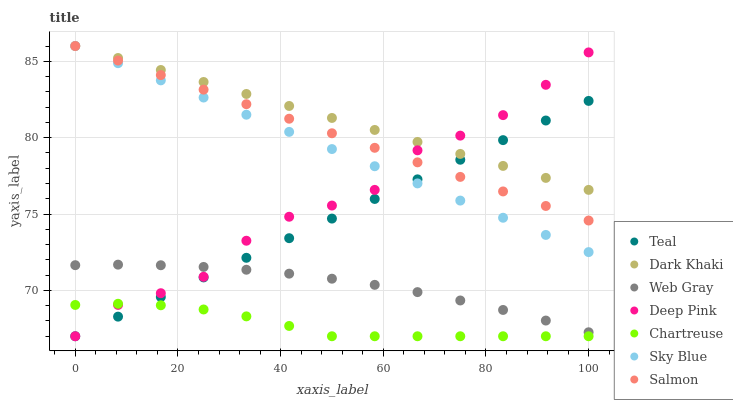Does Chartreuse have the minimum area under the curve?
Answer yes or no. Yes. Does Dark Khaki have the maximum area under the curve?
Answer yes or no. Yes. Does Salmon have the minimum area under the curve?
Answer yes or no. No. Does Salmon have the maximum area under the curve?
Answer yes or no. No. Is Sky Blue the smoothest?
Answer yes or no. Yes. Is Deep Pink the roughest?
Answer yes or no. Yes. Is Salmon the smoothest?
Answer yes or no. No. Is Salmon the roughest?
Answer yes or no. No. Does Chartreuse have the lowest value?
Answer yes or no. Yes. Does Salmon have the lowest value?
Answer yes or no. No. Does Sky Blue have the highest value?
Answer yes or no. Yes. Does Chartreuse have the highest value?
Answer yes or no. No. Is Web Gray less than Salmon?
Answer yes or no. Yes. Is Sky Blue greater than Web Gray?
Answer yes or no. Yes. Does Deep Pink intersect Dark Khaki?
Answer yes or no. Yes. Is Deep Pink less than Dark Khaki?
Answer yes or no. No. Is Deep Pink greater than Dark Khaki?
Answer yes or no. No. Does Web Gray intersect Salmon?
Answer yes or no. No. 